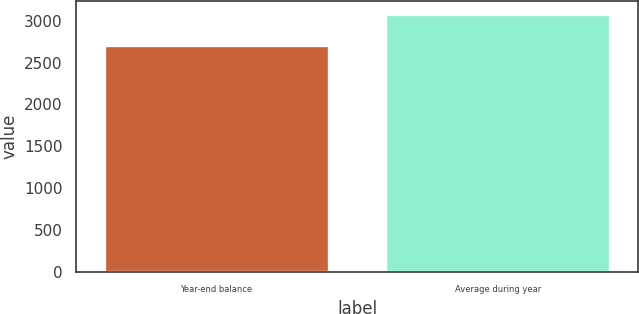Convert chart. <chart><loc_0><loc_0><loc_500><loc_500><bar_chart><fcel>Year-end balance<fcel>Average during year<nl><fcel>2711<fcel>3081<nl></chart> 